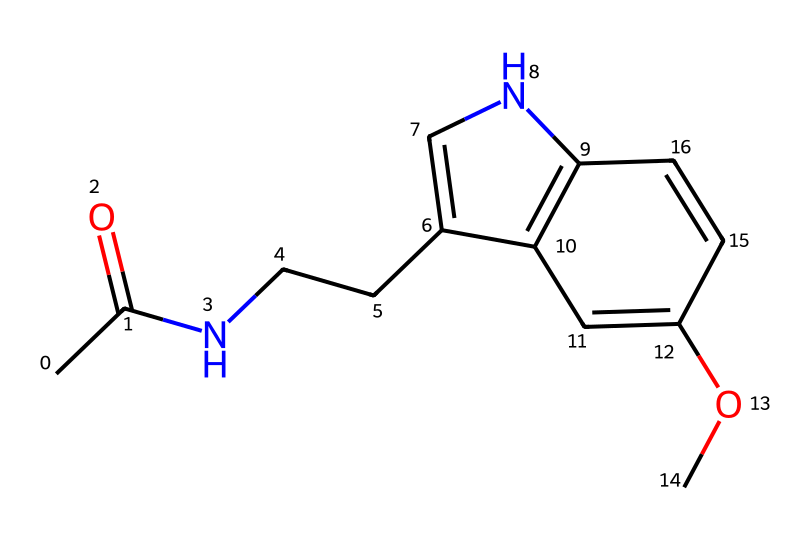What is the molecular formula of this compound? The SMILES representation provides information on the structure, allowing us to count the number of each type of atom present. In this case, there are 13 carbon (C) atoms, 16 hydrogen (H) atoms, 2 nitrogen (N) atoms, and 3 oxygen (O) atoms, leading to the molecular formula C13H16N2O3.
Answer: C13H16N2O3 How many rings are present in the structure? By examining the structure derived from the SMILES, we can identify parts of the molecule that are cyclical. There are two cyclic components in this compound, indicating that there are two rings.
Answer: 2 What type of functional groups are present in this compound? The structure contains a carbonyl (acetyl) group (CC(=O)), a methoxy group (OC), and amine functionality (N). These groups indicate that the compound is an amide with aromatic properties, confirming its classification in terms of functional groups.
Answer: amide, methoxy Is this compound a polar or non-polar substance? The presence of polar functional groups like the carbonyl and the amine contributes to the overall polarity of the molecule, while the larger hydrocarbon part tends to be non-polar. However, due to the presence of significant polar groups, it is deemed polar overall.
Answer: polar How many nitrogen atoms are present in the molecular structure? From the SMILES string, we can directly observe the presence of nitrogen atoms indicated by the letter "N." Counting them reveals there are two nitrogen atoms in total in the molecule.
Answer: 2 Does this structure represent a saturated or unsaturated compound? By analyzing the carbon framework and the presence of double bonds (evident at the carbonyl group), we see that there are both single and double bonds in the molecule, indicating that it is unsaturated.
Answer: unsaturated 